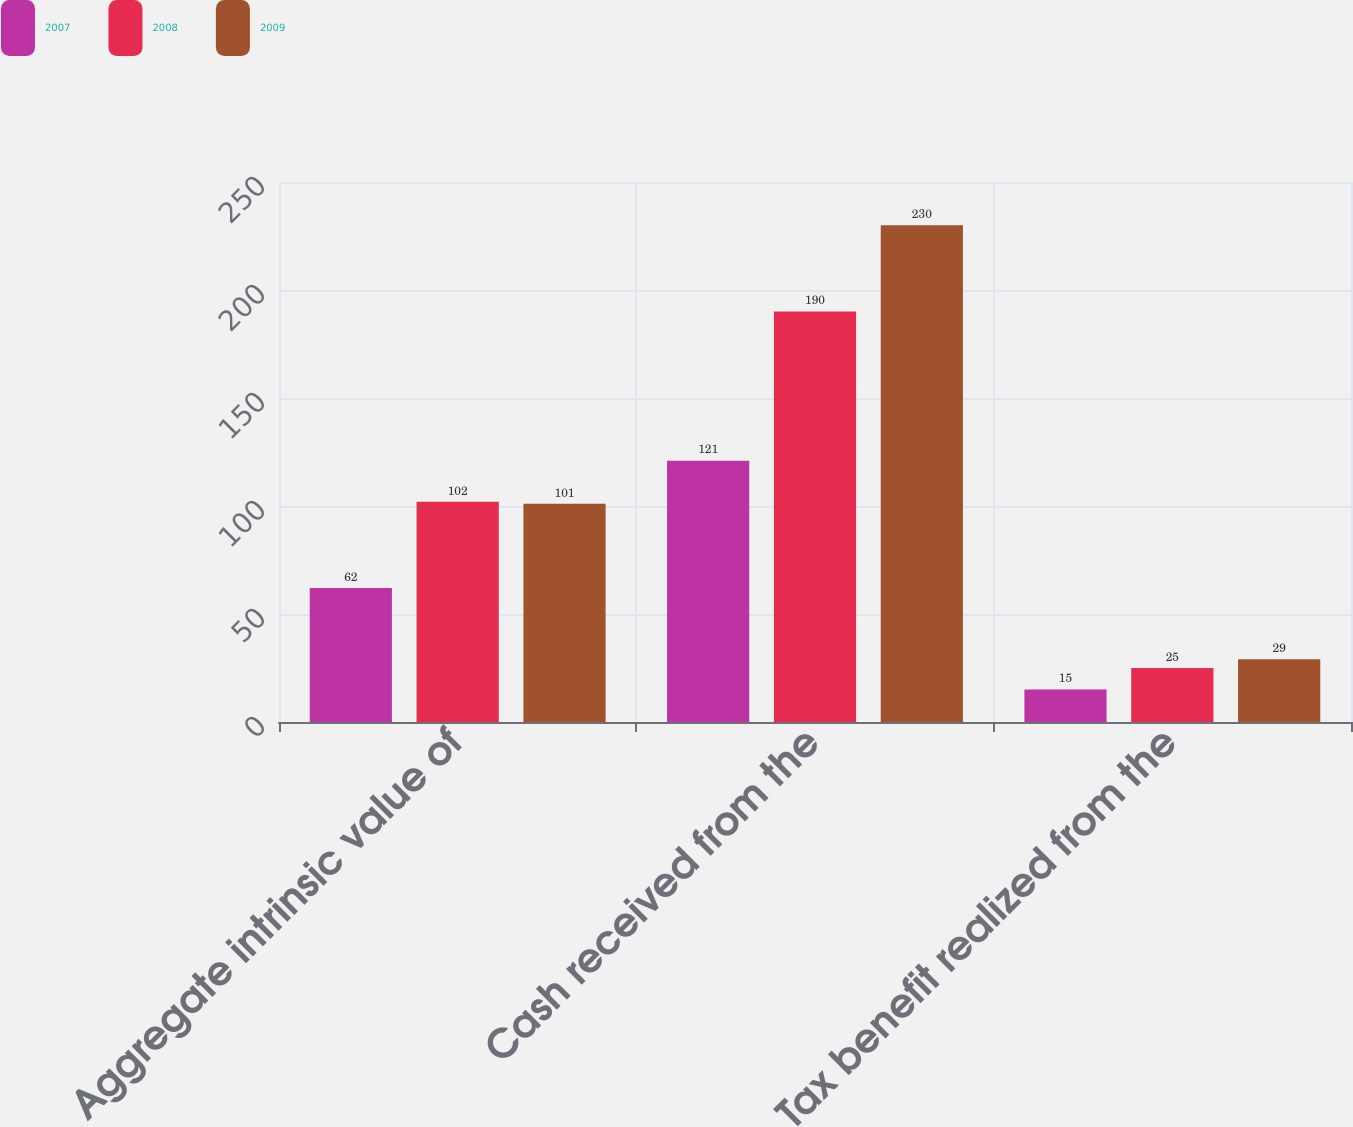Convert chart to OTSL. <chart><loc_0><loc_0><loc_500><loc_500><stacked_bar_chart><ecel><fcel>Aggregate intrinsic value of<fcel>Cash received from the<fcel>Tax benefit realized from the<nl><fcel>2007<fcel>62<fcel>121<fcel>15<nl><fcel>2008<fcel>102<fcel>190<fcel>25<nl><fcel>2009<fcel>101<fcel>230<fcel>29<nl></chart> 